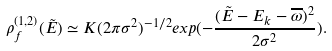Convert formula to latex. <formula><loc_0><loc_0><loc_500><loc_500>\rho _ { f } ^ { ( 1 , 2 ) } ( \tilde { E } ) \simeq K ( 2 \pi \sigma ^ { 2 } ) ^ { - 1 / 2 } e x p ( - \frac { ( \tilde { E } - E _ { k } - \overline { \omega } ) ^ { 2 } } { 2 \sigma ^ { 2 } } ) .</formula> 